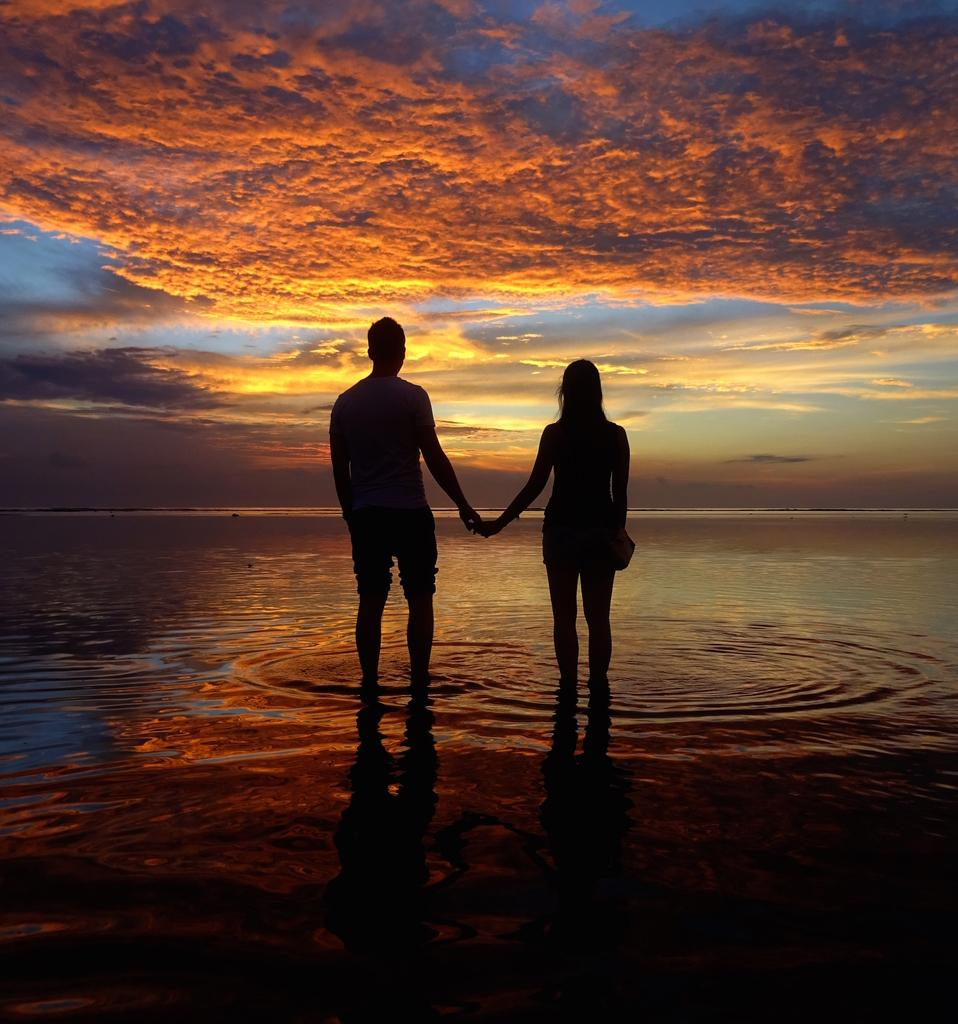How many people are in the image? There are two persons standing in the image. What are the two persons doing? The two persons are holding their hands. What can be seen in the background of the image? There is water and sky visible in the background of the image. Reasoning: Let' Let's think step by step in order to produce the conversation. We start by identifying the number of people in the image, which is two. Then, we describe what they are doing, which is holding their hands. Finally, we mention the background elements, which include water and sky. Absurd Question/Answer: What type of birds can be seen flying in the image? There are no birds visible in the image; it only features two persons holding their hands and the background elements of water and sky. What type of payment is being made by the daughter in the image? There is no daughter or payment present in the image; it only features two persons holding their hands and the background elements of water and sky. 